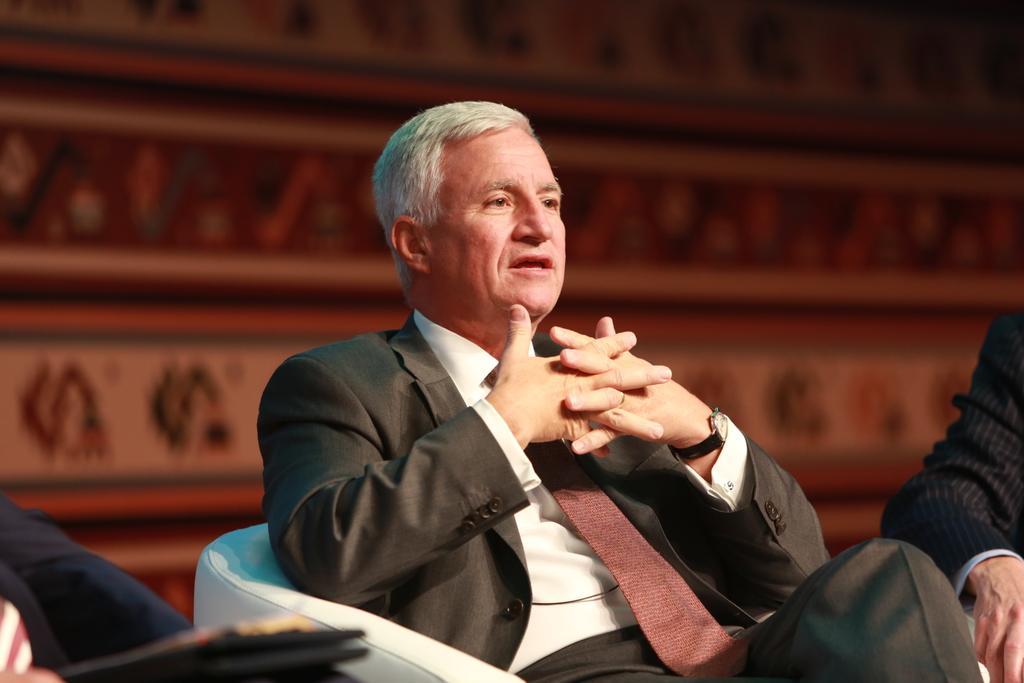Can you describe this image briefly? In this picture I can observe a man sitting in the chair. He is wearing coat and a tie. The background is blurred. 